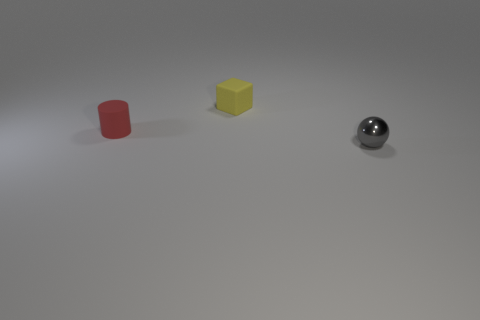What shape is the yellow object?
Offer a terse response. Cube. What is the material of the small object that is in front of the thing that is to the left of the tiny rubber thing that is behind the red cylinder?
Give a very brief answer. Metal. How many things are either small red rubber cylinders or small gray metallic things?
Your answer should be compact. 2. Does the thing that is in front of the red object have the same material as the tiny yellow thing?
Give a very brief answer. No. How many things are small rubber objects that are left of the tiny matte block or large blue matte cylinders?
Give a very brief answer. 1. What color is the small cube that is made of the same material as the small cylinder?
Ensure brevity in your answer.  Yellow. Is there a blue cylinder that has the same size as the ball?
Provide a short and direct response. No. Do the rubber object that is in front of the tiny yellow matte block and the ball have the same color?
Give a very brief answer. No. There is a small object that is both on the right side of the red matte cylinder and in front of the yellow object; what color is it?
Offer a very short reply. Gray. The gray thing that is the same size as the yellow matte thing is what shape?
Provide a short and direct response. Sphere. 